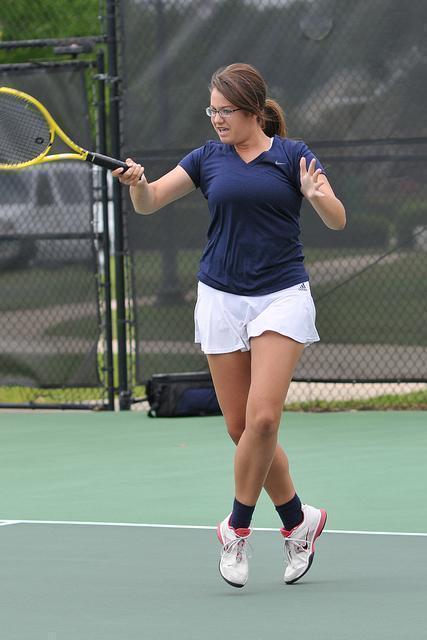What brand skirt she worn?
Select the accurate answer and provide justification: `Answer: choice
Rationale: srationale.`
Options: Adidas, nike, asics, puma. Answer: adidas.
Rationale: The logo is on the skirt and the logo is adidas 